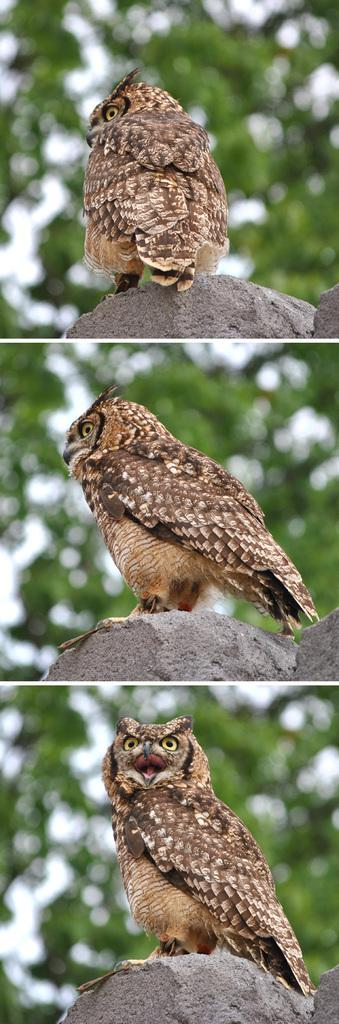What type of artwork is depicted in the image? The image is a collage. What animal can be seen in the image? There is a bird in the image. Where is the bird located in the image? The bird is on a rock. What type of vegetation is visible in the background of the image? There are trees in the background of the image. How would you describe the background of the image? The background is blurry. How does the bird pull the sheep in the image? There are no sheep present in the image, so the bird cannot pull any sheep. 